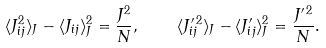<formula> <loc_0><loc_0><loc_500><loc_500>\langle J _ { i j } ^ { 2 } \rangle _ { J } - \langle J _ { i j } \rangle _ { J } ^ { 2 } = \frac { J ^ { 2 } } { N } , \quad \langle J ^ { \prime \, 2 } _ { i j } \rangle _ { J } - \langle J ^ { \prime } _ { i j } \rangle _ { J } ^ { 2 } = \frac { J ^ { \prime \, 2 } } { N } .</formula> 